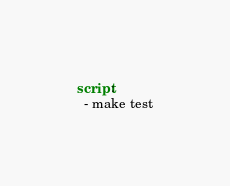Convert code to text. <code><loc_0><loc_0><loc_500><loc_500><_YAML_>script:
  - make test
</code> 